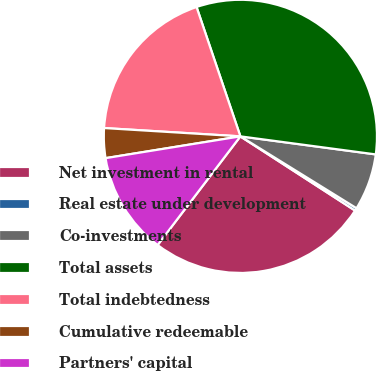Convert chart. <chart><loc_0><loc_0><loc_500><loc_500><pie_chart><fcel>Net investment in rental<fcel>Real estate under development<fcel>Co-investments<fcel>Total assets<fcel>Total indebtedness<fcel>Cumulative redeemable<fcel>Partners' capital<nl><fcel>26.22%<fcel>0.32%<fcel>6.71%<fcel>32.31%<fcel>18.83%<fcel>3.52%<fcel>12.09%<nl></chart> 